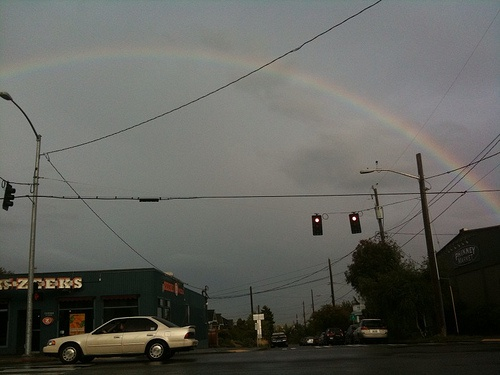Describe the objects in this image and their specific colors. I can see car in gray, black, tan, and olive tones, car in gray and black tones, car in gray and black tones, traffic light in gray, black, maroon, and white tones, and traffic light in gray, black, maroon, and white tones in this image. 